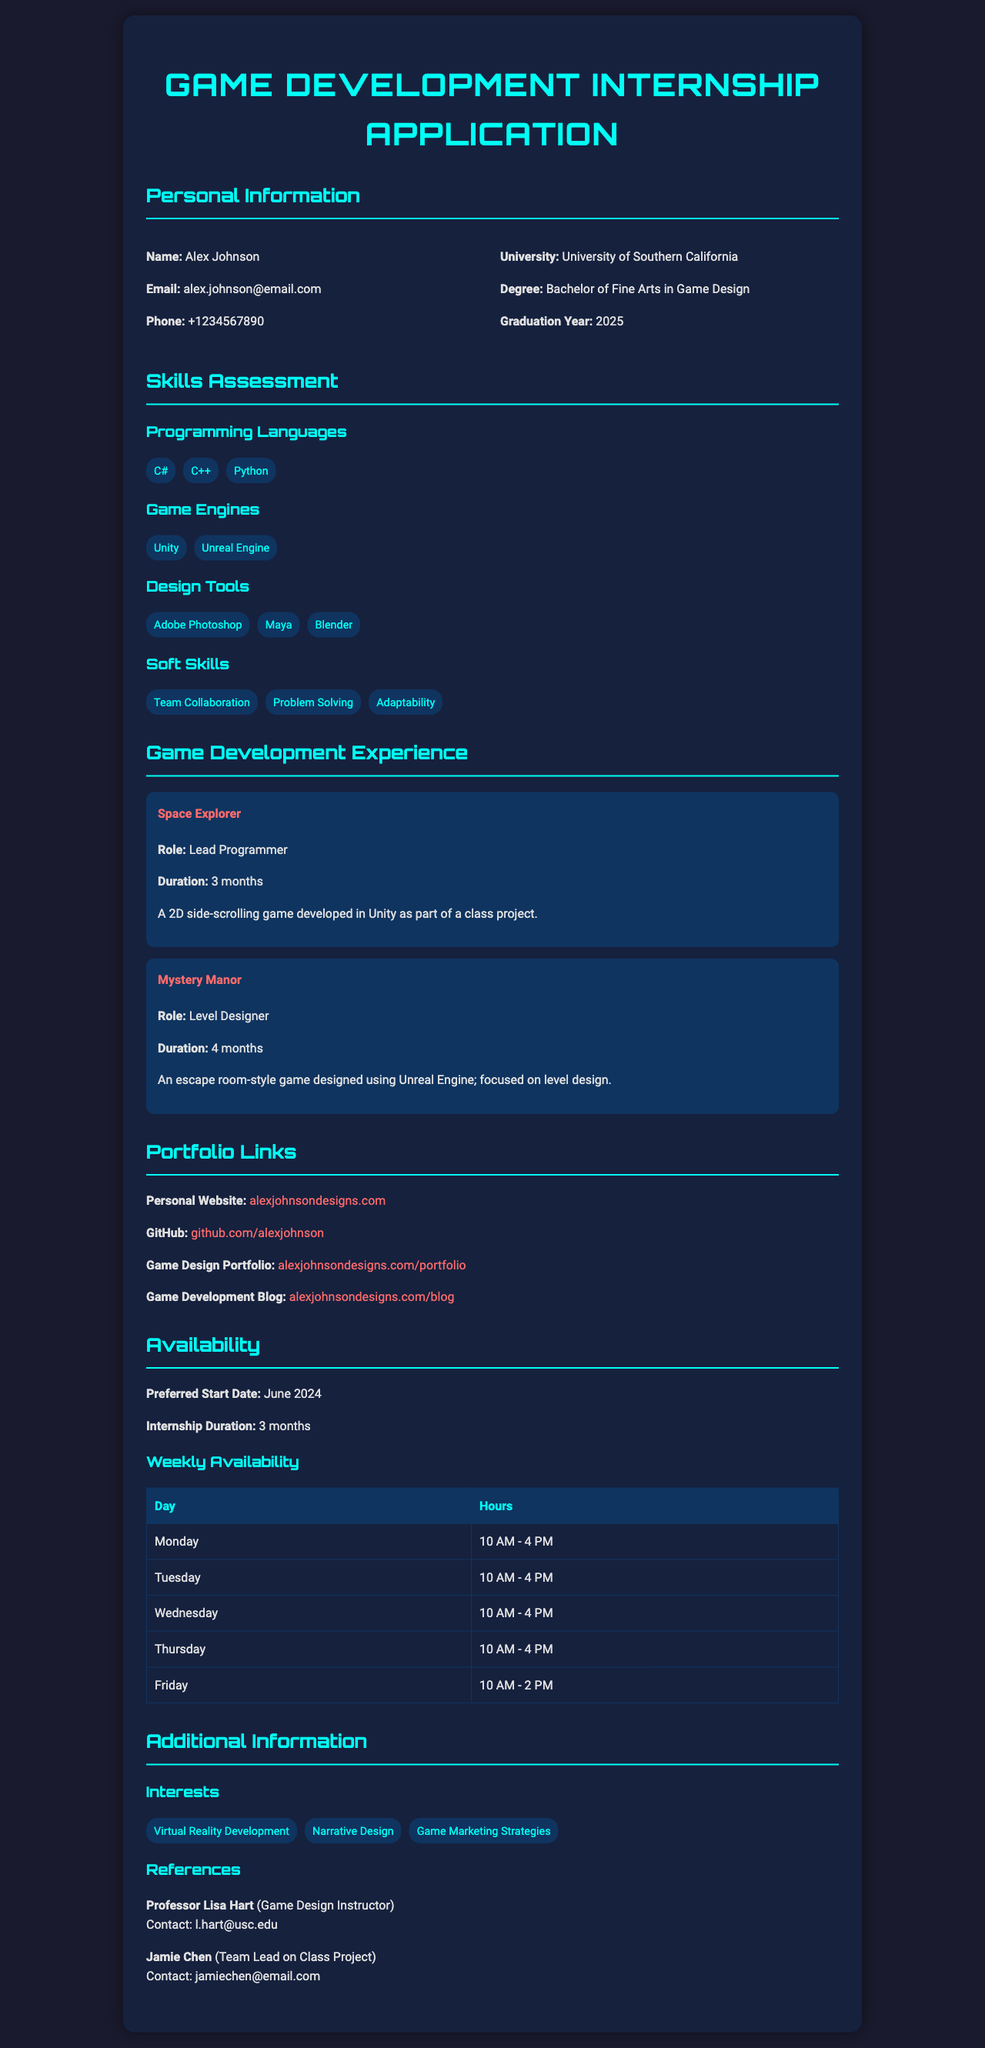What is the name of the applicant? The applicant's name is located at the top section of the document, specified as "Alex Johnson."
Answer: Alex Johnson What is the applicant's email address? The applicant's email address is provided in the personal information section, written as "alex.johnson@email.com."
Answer: alex.johnson@email.com Which university is the applicant attending? The university is mentioned in the personal information section as "University of Southern California."
Answer: University of Southern California What programming languages does the applicant know? The programming languages are listed in the skills assessment section, which includes "C#, C++, Python."
Answer: C#, C++, Python What is the duration of the internship the applicant is requesting? The duration is stated in the availability section as "3 months."
Answer: 3 months What role did the applicant have in the game "Space Explorer"? The role is specified under game development experience, stating "Lead Programmer."
Answer: Lead Programmer What is the preferred start date for the internship? The preferred start date is mentioned in the availability section, which is "June 2024."
Answer: June 2024 How many weekly hours is the applicant available on Friday? The availability on Friday is listed in the weekly availability table as "10 AM - 2 PM."
Answer: 10 AM - 2 PM Which game engine does the applicant have experience with? The game engines listed are in the skills assessment section, including "Unity" and "Unreal Engine."
Answer: Unity, Unreal Engine 